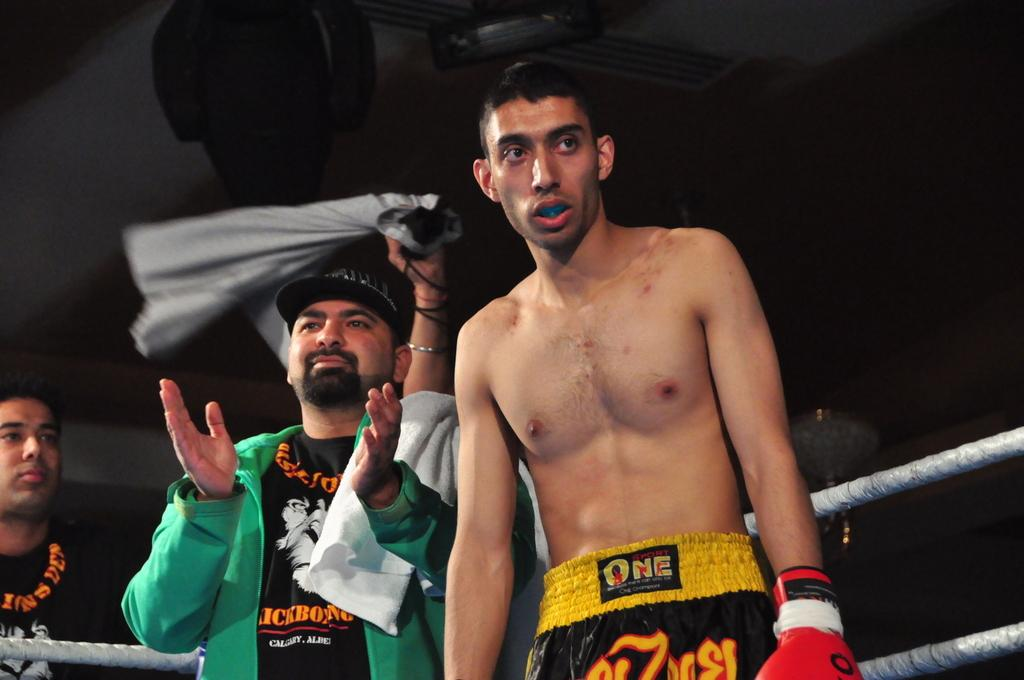Provide a one-sentence caption for the provided image. A man in a green jacket, with a towel over his shoulder is clapping as a boxer wearing shorts that say One on the waist stands in front of him. 